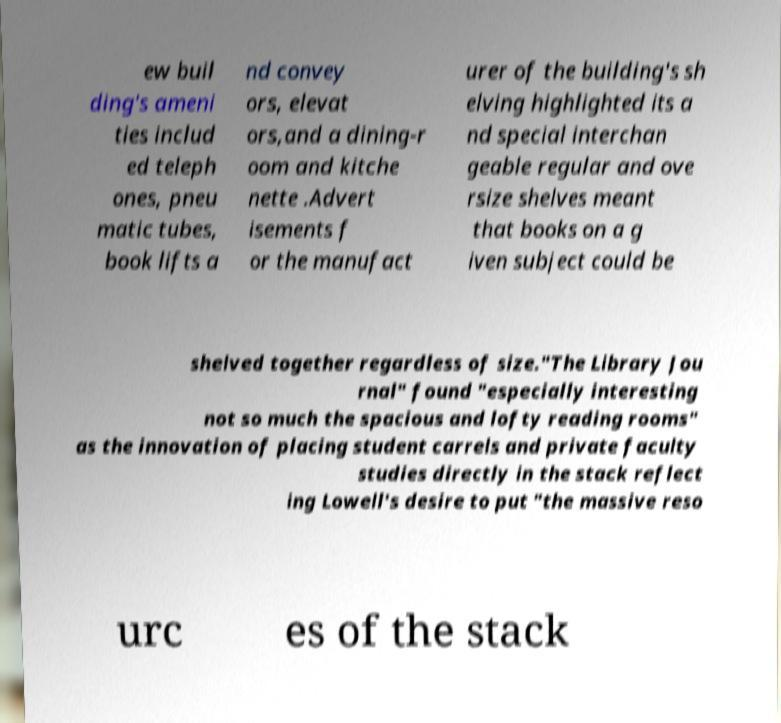Can you accurately transcribe the text from the provided image for me? ew buil ding's ameni ties includ ed teleph ones, pneu matic tubes, book lifts a nd convey ors, elevat ors,and a dining-r oom and kitche nette .Advert isements f or the manufact urer of the building's sh elving highlighted its a nd special interchan geable regular and ove rsize shelves meant that books on a g iven subject could be shelved together regardless of size."The Library Jou rnal" found "especially interesting not so much the spacious and lofty reading rooms" as the innovation of placing student carrels and private faculty studies directly in the stack reflect ing Lowell's desire to put "the massive reso urc es of the stack 